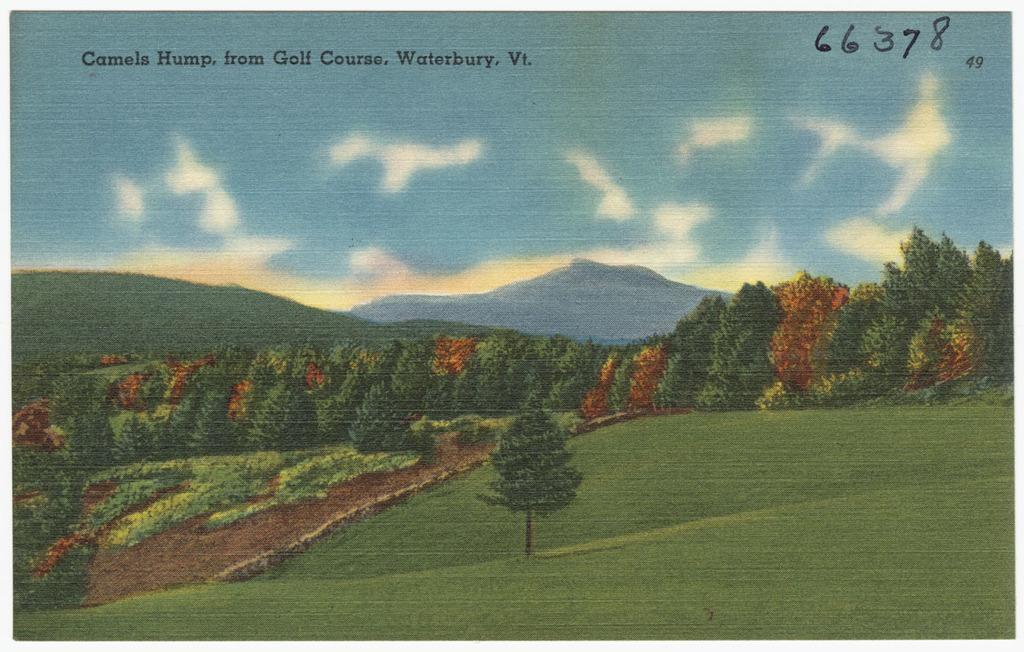What is featured on the poster in the image? The poster contains images of trees, grass, mountains, and clouds in the sky. What type of natural landscapes are depicted on the poster? The poster depicts images of trees, grass, and mountains, which are all natural landscapes. Where is the text located on the poster? The text is at the top of the poster. What type of lettuce is being served at the meeting in the image? There is no meeting or lettuce present in the image; it only features a poster with images of trees, grass, mountains, and clouds in the sky. 